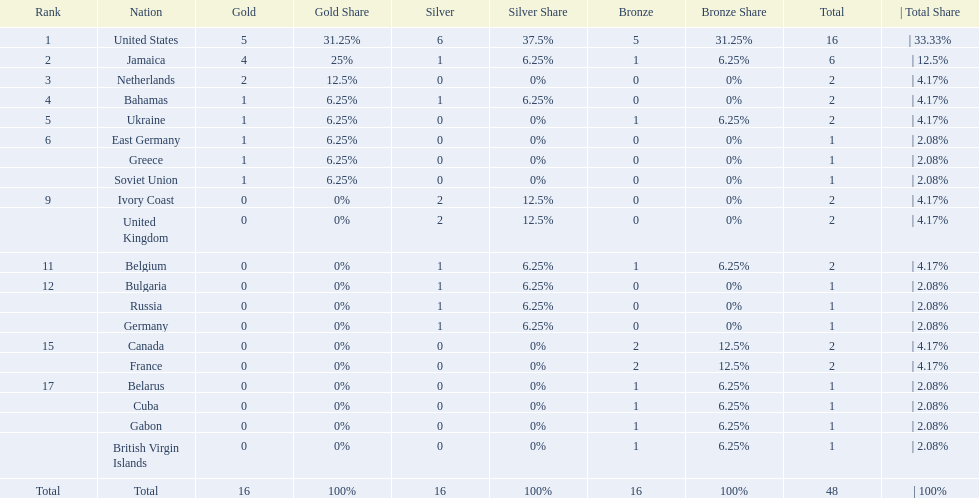What is the total number of gold medals won by jamaica? 4. 